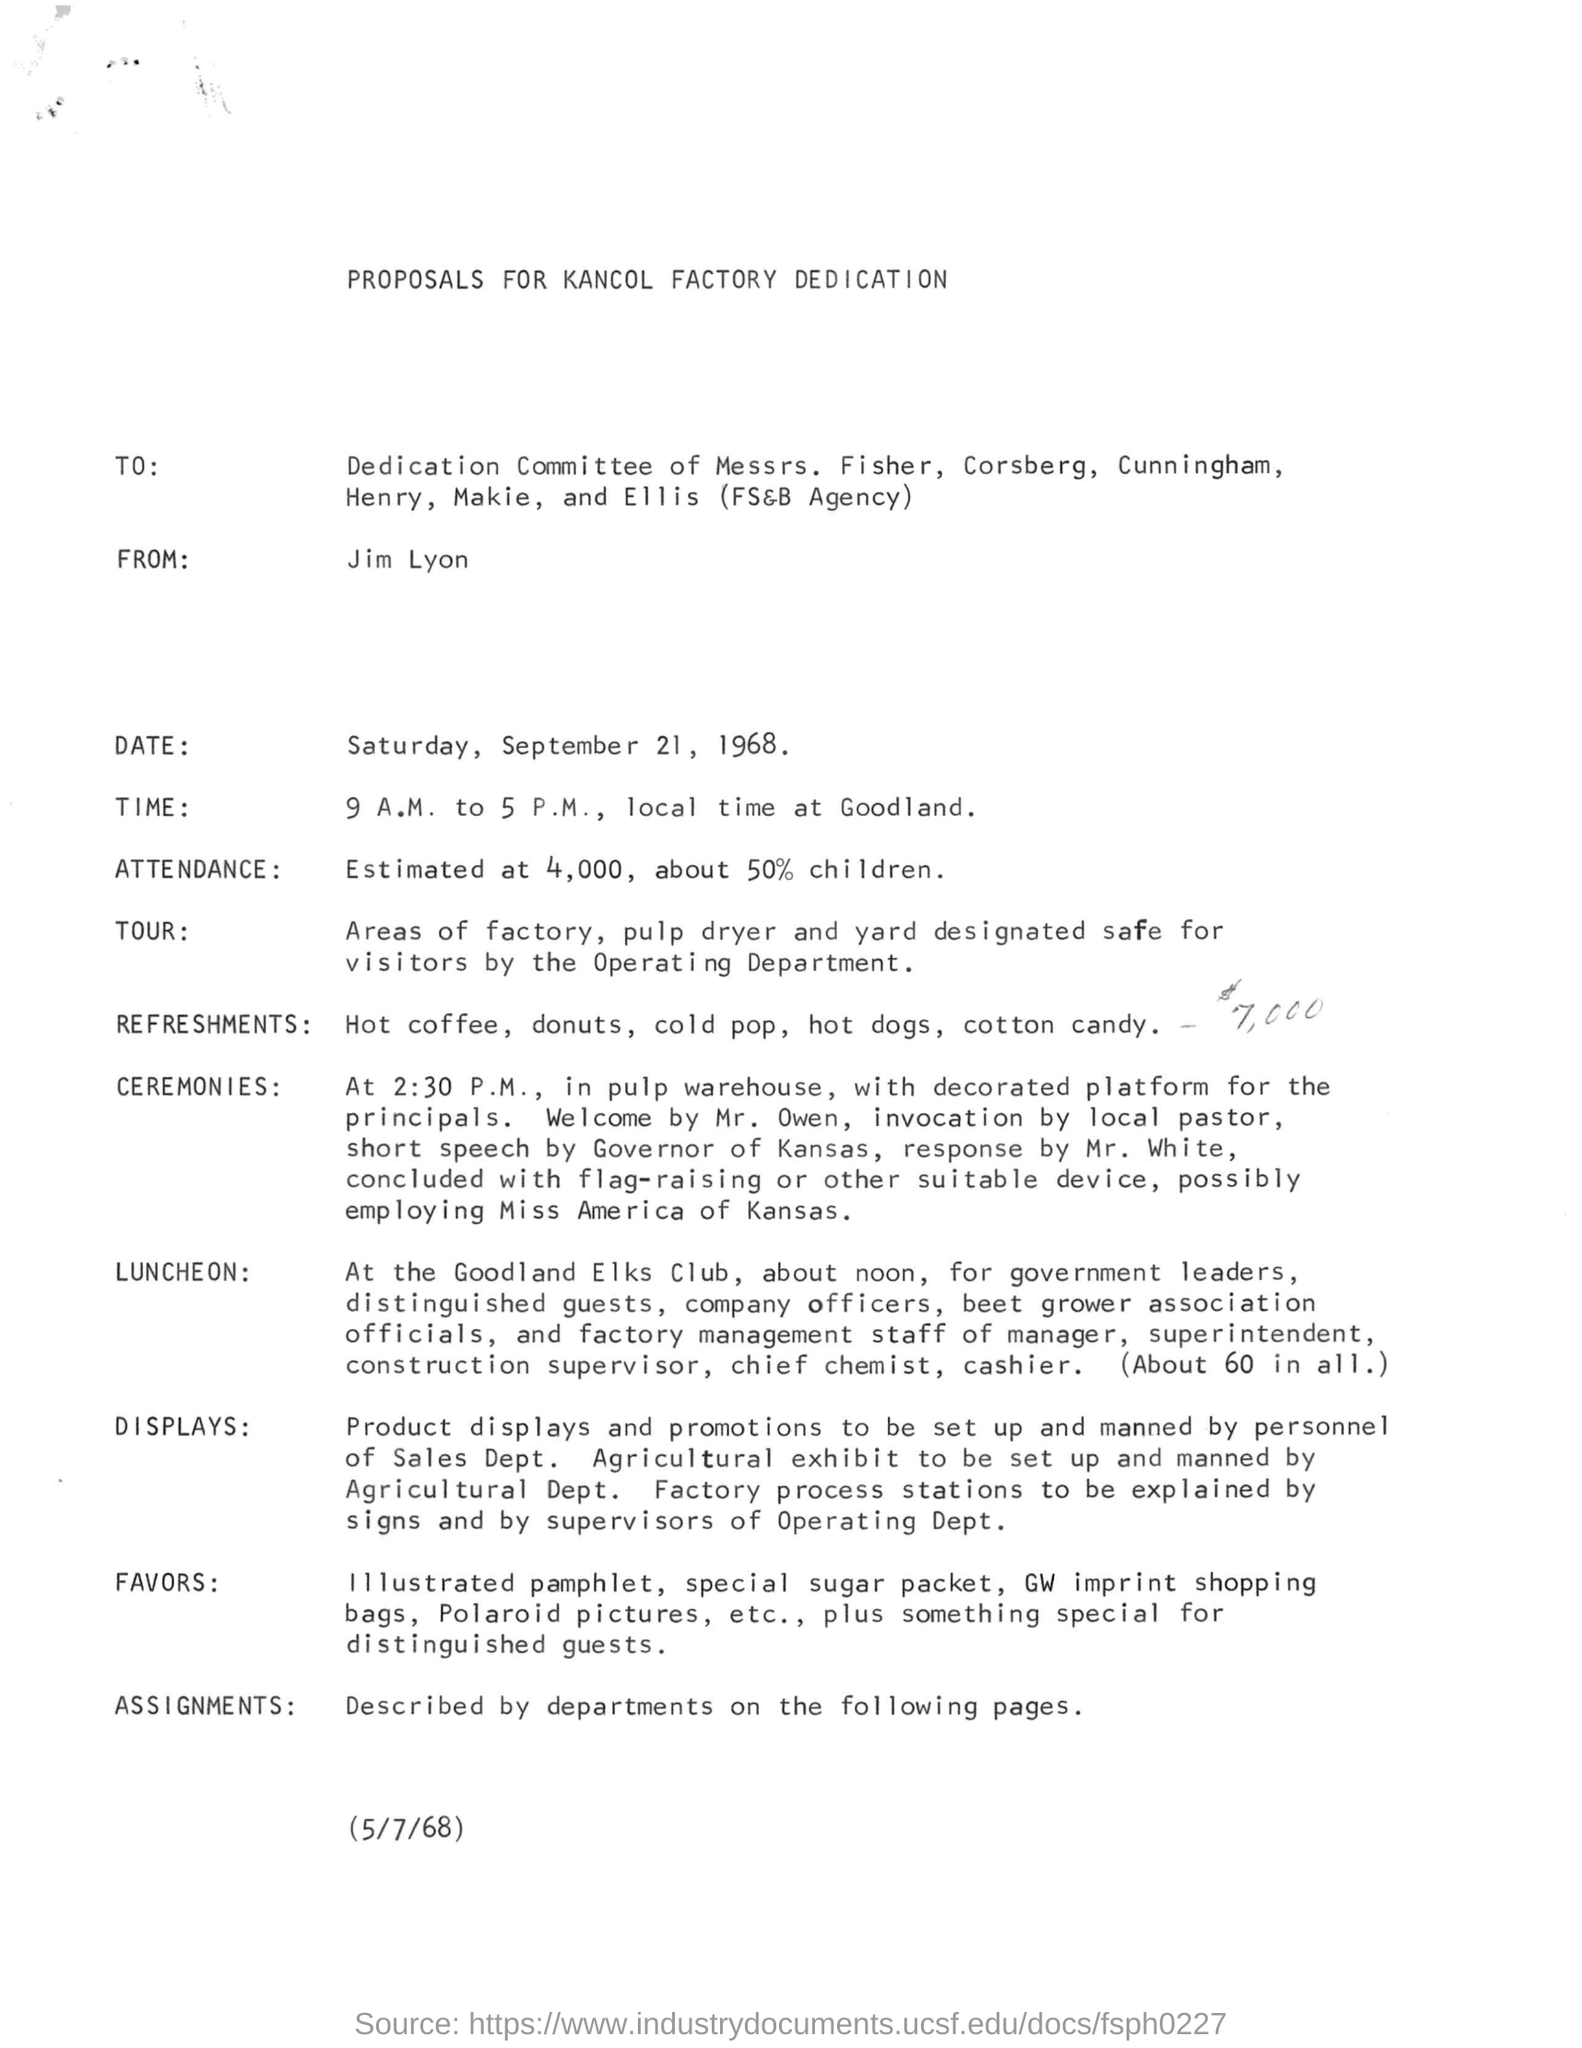Who is mentioned in the FROM?
Provide a succinct answer. JIM LYON. Which is the date of the ceremony?
Your response must be concise. SATURDAY, SEPTEMBER 21, 1968. Who is the sender of this proposal?
Your answer should be very brief. Jim Lyon. Where is the LUNCHEON scheduled?
Your answer should be compact. At the Goodland Elks Club. 